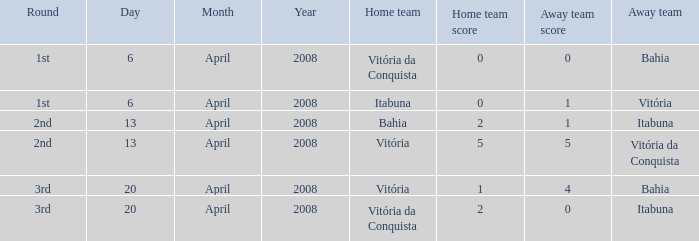When itabuna was the away team on april 13, 2008, what was the name of the home team? Bahia. 